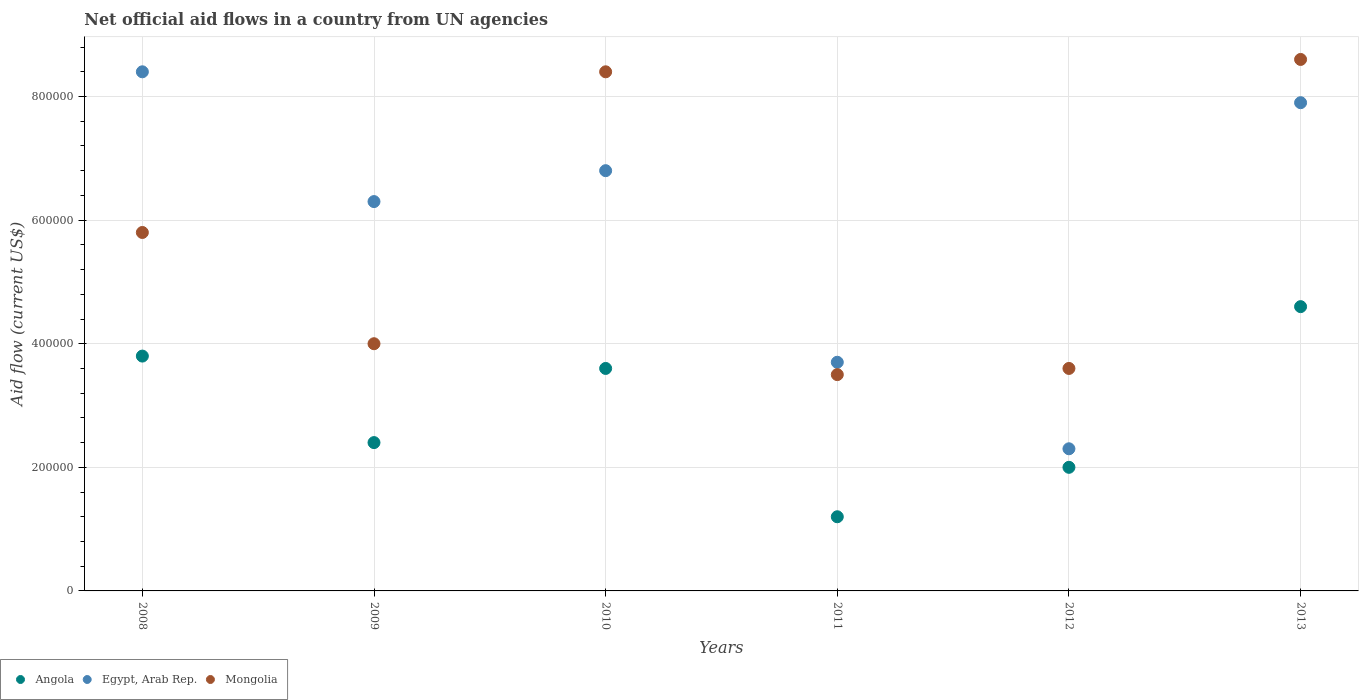How many different coloured dotlines are there?
Keep it short and to the point. 3. What is the net official aid flow in Egypt, Arab Rep. in 2013?
Give a very brief answer. 7.90e+05. Across all years, what is the maximum net official aid flow in Mongolia?
Give a very brief answer. 8.60e+05. Across all years, what is the minimum net official aid flow in Egypt, Arab Rep.?
Offer a terse response. 2.30e+05. In which year was the net official aid flow in Angola maximum?
Offer a very short reply. 2013. In which year was the net official aid flow in Egypt, Arab Rep. minimum?
Keep it short and to the point. 2012. What is the total net official aid flow in Angola in the graph?
Make the answer very short. 1.76e+06. What is the difference between the net official aid flow in Mongolia in 2010 and that in 2012?
Ensure brevity in your answer.  4.80e+05. What is the difference between the net official aid flow in Mongolia in 2013 and the net official aid flow in Angola in 2012?
Ensure brevity in your answer.  6.60e+05. What is the average net official aid flow in Mongolia per year?
Give a very brief answer. 5.65e+05. In the year 2013, what is the difference between the net official aid flow in Angola and net official aid flow in Egypt, Arab Rep.?
Give a very brief answer. -3.30e+05. What is the ratio of the net official aid flow in Angola in 2008 to that in 2010?
Your answer should be very brief. 1.06. Is the difference between the net official aid flow in Angola in 2010 and 2012 greater than the difference between the net official aid flow in Egypt, Arab Rep. in 2010 and 2012?
Your response must be concise. No. What is the difference between the highest and the lowest net official aid flow in Egypt, Arab Rep.?
Offer a very short reply. 6.10e+05. How many years are there in the graph?
Provide a succinct answer. 6. Does the graph contain grids?
Make the answer very short. Yes. Where does the legend appear in the graph?
Your answer should be very brief. Bottom left. What is the title of the graph?
Your answer should be compact. Net official aid flows in a country from UN agencies. What is the label or title of the Y-axis?
Your answer should be very brief. Aid flow (current US$). What is the Aid flow (current US$) in Egypt, Arab Rep. in 2008?
Your answer should be compact. 8.40e+05. What is the Aid flow (current US$) of Mongolia in 2008?
Keep it short and to the point. 5.80e+05. What is the Aid flow (current US$) of Egypt, Arab Rep. in 2009?
Make the answer very short. 6.30e+05. What is the Aid flow (current US$) in Mongolia in 2009?
Your response must be concise. 4.00e+05. What is the Aid flow (current US$) of Egypt, Arab Rep. in 2010?
Offer a terse response. 6.80e+05. What is the Aid flow (current US$) in Mongolia in 2010?
Your answer should be compact. 8.40e+05. What is the Aid flow (current US$) in Mongolia in 2011?
Your answer should be compact. 3.50e+05. What is the Aid flow (current US$) in Egypt, Arab Rep. in 2012?
Provide a succinct answer. 2.30e+05. What is the Aid flow (current US$) of Mongolia in 2012?
Keep it short and to the point. 3.60e+05. What is the Aid flow (current US$) in Angola in 2013?
Offer a very short reply. 4.60e+05. What is the Aid flow (current US$) of Egypt, Arab Rep. in 2013?
Keep it short and to the point. 7.90e+05. What is the Aid flow (current US$) in Mongolia in 2013?
Provide a succinct answer. 8.60e+05. Across all years, what is the maximum Aid flow (current US$) in Egypt, Arab Rep.?
Provide a succinct answer. 8.40e+05. Across all years, what is the maximum Aid flow (current US$) of Mongolia?
Give a very brief answer. 8.60e+05. Across all years, what is the minimum Aid flow (current US$) in Angola?
Your answer should be very brief. 1.20e+05. Across all years, what is the minimum Aid flow (current US$) in Mongolia?
Offer a terse response. 3.50e+05. What is the total Aid flow (current US$) in Angola in the graph?
Keep it short and to the point. 1.76e+06. What is the total Aid flow (current US$) in Egypt, Arab Rep. in the graph?
Your response must be concise. 3.54e+06. What is the total Aid flow (current US$) in Mongolia in the graph?
Offer a terse response. 3.39e+06. What is the difference between the Aid flow (current US$) in Angola in 2008 and that in 2009?
Your answer should be compact. 1.40e+05. What is the difference between the Aid flow (current US$) of Egypt, Arab Rep. in 2008 and that in 2009?
Provide a succinct answer. 2.10e+05. What is the difference between the Aid flow (current US$) in Mongolia in 2008 and that in 2009?
Offer a very short reply. 1.80e+05. What is the difference between the Aid flow (current US$) in Angola in 2008 and that in 2010?
Offer a very short reply. 2.00e+04. What is the difference between the Aid flow (current US$) in Mongolia in 2008 and that in 2011?
Your answer should be very brief. 2.30e+05. What is the difference between the Aid flow (current US$) in Angola in 2008 and that in 2012?
Make the answer very short. 1.80e+05. What is the difference between the Aid flow (current US$) of Mongolia in 2008 and that in 2012?
Give a very brief answer. 2.20e+05. What is the difference between the Aid flow (current US$) of Angola in 2008 and that in 2013?
Offer a terse response. -8.00e+04. What is the difference between the Aid flow (current US$) in Mongolia in 2008 and that in 2013?
Offer a terse response. -2.80e+05. What is the difference between the Aid flow (current US$) in Angola in 2009 and that in 2010?
Your answer should be very brief. -1.20e+05. What is the difference between the Aid flow (current US$) in Egypt, Arab Rep. in 2009 and that in 2010?
Keep it short and to the point. -5.00e+04. What is the difference between the Aid flow (current US$) in Mongolia in 2009 and that in 2010?
Your answer should be very brief. -4.40e+05. What is the difference between the Aid flow (current US$) in Angola in 2009 and that in 2011?
Your response must be concise. 1.20e+05. What is the difference between the Aid flow (current US$) of Mongolia in 2009 and that in 2011?
Ensure brevity in your answer.  5.00e+04. What is the difference between the Aid flow (current US$) in Mongolia in 2009 and that in 2012?
Your answer should be compact. 4.00e+04. What is the difference between the Aid flow (current US$) in Mongolia in 2009 and that in 2013?
Keep it short and to the point. -4.60e+05. What is the difference between the Aid flow (current US$) of Angola in 2010 and that in 2011?
Your response must be concise. 2.40e+05. What is the difference between the Aid flow (current US$) of Egypt, Arab Rep. in 2010 and that in 2011?
Offer a very short reply. 3.10e+05. What is the difference between the Aid flow (current US$) of Angola in 2010 and that in 2012?
Offer a very short reply. 1.60e+05. What is the difference between the Aid flow (current US$) in Mongolia in 2010 and that in 2012?
Ensure brevity in your answer.  4.80e+05. What is the difference between the Aid flow (current US$) in Angola in 2010 and that in 2013?
Your answer should be compact. -1.00e+05. What is the difference between the Aid flow (current US$) of Egypt, Arab Rep. in 2010 and that in 2013?
Your answer should be compact. -1.10e+05. What is the difference between the Aid flow (current US$) in Mongolia in 2010 and that in 2013?
Your answer should be very brief. -2.00e+04. What is the difference between the Aid flow (current US$) of Angola in 2011 and that in 2012?
Provide a short and direct response. -8.00e+04. What is the difference between the Aid flow (current US$) of Egypt, Arab Rep. in 2011 and that in 2012?
Make the answer very short. 1.40e+05. What is the difference between the Aid flow (current US$) in Mongolia in 2011 and that in 2012?
Keep it short and to the point. -10000. What is the difference between the Aid flow (current US$) in Angola in 2011 and that in 2013?
Your answer should be very brief. -3.40e+05. What is the difference between the Aid flow (current US$) of Egypt, Arab Rep. in 2011 and that in 2013?
Your answer should be very brief. -4.20e+05. What is the difference between the Aid flow (current US$) of Mongolia in 2011 and that in 2013?
Give a very brief answer. -5.10e+05. What is the difference between the Aid flow (current US$) in Angola in 2012 and that in 2013?
Keep it short and to the point. -2.60e+05. What is the difference between the Aid flow (current US$) of Egypt, Arab Rep. in 2012 and that in 2013?
Give a very brief answer. -5.60e+05. What is the difference between the Aid flow (current US$) in Mongolia in 2012 and that in 2013?
Your answer should be very brief. -5.00e+05. What is the difference between the Aid flow (current US$) in Angola in 2008 and the Aid flow (current US$) in Mongolia in 2009?
Ensure brevity in your answer.  -2.00e+04. What is the difference between the Aid flow (current US$) of Angola in 2008 and the Aid flow (current US$) of Egypt, Arab Rep. in 2010?
Make the answer very short. -3.00e+05. What is the difference between the Aid flow (current US$) of Angola in 2008 and the Aid flow (current US$) of Mongolia in 2010?
Your response must be concise. -4.60e+05. What is the difference between the Aid flow (current US$) of Angola in 2008 and the Aid flow (current US$) of Mongolia in 2011?
Your answer should be compact. 3.00e+04. What is the difference between the Aid flow (current US$) of Egypt, Arab Rep. in 2008 and the Aid flow (current US$) of Mongolia in 2012?
Make the answer very short. 4.80e+05. What is the difference between the Aid flow (current US$) of Angola in 2008 and the Aid flow (current US$) of Egypt, Arab Rep. in 2013?
Offer a very short reply. -4.10e+05. What is the difference between the Aid flow (current US$) in Angola in 2008 and the Aid flow (current US$) in Mongolia in 2013?
Keep it short and to the point. -4.80e+05. What is the difference between the Aid flow (current US$) of Angola in 2009 and the Aid flow (current US$) of Egypt, Arab Rep. in 2010?
Offer a very short reply. -4.40e+05. What is the difference between the Aid flow (current US$) in Angola in 2009 and the Aid flow (current US$) in Mongolia in 2010?
Offer a terse response. -6.00e+05. What is the difference between the Aid flow (current US$) in Egypt, Arab Rep. in 2009 and the Aid flow (current US$) in Mongolia in 2010?
Your answer should be compact. -2.10e+05. What is the difference between the Aid flow (current US$) in Angola in 2009 and the Aid flow (current US$) in Mongolia in 2011?
Offer a very short reply. -1.10e+05. What is the difference between the Aid flow (current US$) of Angola in 2009 and the Aid flow (current US$) of Egypt, Arab Rep. in 2012?
Give a very brief answer. 10000. What is the difference between the Aid flow (current US$) of Angola in 2009 and the Aid flow (current US$) of Egypt, Arab Rep. in 2013?
Ensure brevity in your answer.  -5.50e+05. What is the difference between the Aid flow (current US$) in Angola in 2009 and the Aid flow (current US$) in Mongolia in 2013?
Provide a succinct answer. -6.20e+05. What is the difference between the Aid flow (current US$) of Angola in 2010 and the Aid flow (current US$) of Mongolia in 2012?
Offer a terse response. 0. What is the difference between the Aid flow (current US$) of Egypt, Arab Rep. in 2010 and the Aid flow (current US$) of Mongolia in 2012?
Make the answer very short. 3.20e+05. What is the difference between the Aid flow (current US$) of Angola in 2010 and the Aid flow (current US$) of Egypt, Arab Rep. in 2013?
Your answer should be very brief. -4.30e+05. What is the difference between the Aid flow (current US$) in Angola in 2010 and the Aid flow (current US$) in Mongolia in 2013?
Your answer should be compact. -5.00e+05. What is the difference between the Aid flow (current US$) in Angola in 2011 and the Aid flow (current US$) in Egypt, Arab Rep. in 2012?
Your answer should be compact. -1.10e+05. What is the difference between the Aid flow (current US$) in Angola in 2011 and the Aid flow (current US$) in Egypt, Arab Rep. in 2013?
Ensure brevity in your answer.  -6.70e+05. What is the difference between the Aid flow (current US$) in Angola in 2011 and the Aid flow (current US$) in Mongolia in 2013?
Ensure brevity in your answer.  -7.40e+05. What is the difference between the Aid flow (current US$) in Egypt, Arab Rep. in 2011 and the Aid flow (current US$) in Mongolia in 2013?
Ensure brevity in your answer.  -4.90e+05. What is the difference between the Aid flow (current US$) in Angola in 2012 and the Aid flow (current US$) in Egypt, Arab Rep. in 2013?
Offer a very short reply. -5.90e+05. What is the difference between the Aid flow (current US$) in Angola in 2012 and the Aid flow (current US$) in Mongolia in 2013?
Offer a terse response. -6.60e+05. What is the difference between the Aid flow (current US$) of Egypt, Arab Rep. in 2012 and the Aid flow (current US$) of Mongolia in 2013?
Provide a succinct answer. -6.30e+05. What is the average Aid flow (current US$) of Angola per year?
Your response must be concise. 2.93e+05. What is the average Aid flow (current US$) in Egypt, Arab Rep. per year?
Your answer should be very brief. 5.90e+05. What is the average Aid flow (current US$) in Mongolia per year?
Provide a succinct answer. 5.65e+05. In the year 2008, what is the difference between the Aid flow (current US$) in Angola and Aid flow (current US$) in Egypt, Arab Rep.?
Make the answer very short. -4.60e+05. In the year 2008, what is the difference between the Aid flow (current US$) of Egypt, Arab Rep. and Aid flow (current US$) of Mongolia?
Give a very brief answer. 2.60e+05. In the year 2009, what is the difference between the Aid flow (current US$) of Angola and Aid flow (current US$) of Egypt, Arab Rep.?
Provide a short and direct response. -3.90e+05. In the year 2010, what is the difference between the Aid flow (current US$) of Angola and Aid flow (current US$) of Egypt, Arab Rep.?
Keep it short and to the point. -3.20e+05. In the year 2010, what is the difference between the Aid flow (current US$) in Angola and Aid flow (current US$) in Mongolia?
Keep it short and to the point. -4.80e+05. In the year 2011, what is the difference between the Aid flow (current US$) in Angola and Aid flow (current US$) in Egypt, Arab Rep.?
Your answer should be compact. -2.50e+05. In the year 2011, what is the difference between the Aid flow (current US$) of Egypt, Arab Rep. and Aid flow (current US$) of Mongolia?
Your answer should be very brief. 2.00e+04. In the year 2012, what is the difference between the Aid flow (current US$) in Angola and Aid flow (current US$) in Egypt, Arab Rep.?
Offer a very short reply. -3.00e+04. In the year 2012, what is the difference between the Aid flow (current US$) in Egypt, Arab Rep. and Aid flow (current US$) in Mongolia?
Offer a very short reply. -1.30e+05. In the year 2013, what is the difference between the Aid flow (current US$) in Angola and Aid flow (current US$) in Egypt, Arab Rep.?
Make the answer very short. -3.30e+05. In the year 2013, what is the difference between the Aid flow (current US$) in Angola and Aid flow (current US$) in Mongolia?
Your response must be concise. -4.00e+05. In the year 2013, what is the difference between the Aid flow (current US$) of Egypt, Arab Rep. and Aid flow (current US$) of Mongolia?
Offer a very short reply. -7.00e+04. What is the ratio of the Aid flow (current US$) in Angola in 2008 to that in 2009?
Keep it short and to the point. 1.58. What is the ratio of the Aid flow (current US$) of Mongolia in 2008 to that in 2009?
Make the answer very short. 1.45. What is the ratio of the Aid flow (current US$) of Angola in 2008 to that in 2010?
Your answer should be very brief. 1.06. What is the ratio of the Aid flow (current US$) of Egypt, Arab Rep. in 2008 to that in 2010?
Your answer should be very brief. 1.24. What is the ratio of the Aid flow (current US$) of Mongolia in 2008 to that in 2010?
Ensure brevity in your answer.  0.69. What is the ratio of the Aid flow (current US$) in Angola in 2008 to that in 2011?
Your response must be concise. 3.17. What is the ratio of the Aid flow (current US$) of Egypt, Arab Rep. in 2008 to that in 2011?
Keep it short and to the point. 2.27. What is the ratio of the Aid flow (current US$) in Mongolia in 2008 to that in 2011?
Ensure brevity in your answer.  1.66. What is the ratio of the Aid flow (current US$) of Angola in 2008 to that in 2012?
Your answer should be compact. 1.9. What is the ratio of the Aid flow (current US$) of Egypt, Arab Rep. in 2008 to that in 2012?
Your answer should be compact. 3.65. What is the ratio of the Aid flow (current US$) of Mongolia in 2008 to that in 2012?
Offer a terse response. 1.61. What is the ratio of the Aid flow (current US$) of Angola in 2008 to that in 2013?
Provide a short and direct response. 0.83. What is the ratio of the Aid flow (current US$) in Egypt, Arab Rep. in 2008 to that in 2013?
Provide a short and direct response. 1.06. What is the ratio of the Aid flow (current US$) of Mongolia in 2008 to that in 2013?
Keep it short and to the point. 0.67. What is the ratio of the Aid flow (current US$) of Egypt, Arab Rep. in 2009 to that in 2010?
Provide a succinct answer. 0.93. What is the ratio of the Aid flow (current US$) of Mongolia in 2009 to that in 2010?
Offer a very short reply. 0.48. What is the ratio of the Aid flow (current US$) of Egypt, Arab Rep. in 2009 to that in 2011?
Your answer should be compact. 1.7. What is the ratio of the Aid flow (current US$) in Mongolia in 2009 to that in 2011?
Offer a terse response. 1.14. What is the ratio of the Aid flow (current US$) of Egypt, Arab Rep. in 2009 to that in 2012?
Keep it short and to the point. 2.74. What is the ratio of the Aid flow (current US$) in Angola in 2009 to that in 2013?
Offer a terse response. 0.52. What is the ratio of the Aid flow (current US$) of Egypt, Arab Rep. in 2009 to that in 2013?
Ensure brevity in your answer.  0.8. What is the ratio of the Aid flow (current US$) of Mongolia in 2009 to that in 2013?
Your answer should be compact. 0.47. What is the ratio of the Aid flow (current US$) in Egypt, Arab Rep. in 2010 to that in 2011?
Your answer should be very brief. 1.84. What is the ratio of the Aid flow (current US$) of Egypt, Arab Rep. in 2010 to that in 2012?
Your response must be concise. 2.96. What is the ratio of the Aid flow (current US$) of Mongolia in 2010 to that in 2012?
Give a very brief answer. 2.33. What is the ratio of the Aid flow (current US$) of Angola in 2010 to that in 2013?
Provide a short and direct response. 0.78. What is the ratio of the Aid flow (current US$) of Egypt, Arab Rep. in 2010 to that in 2013?
Keep it short and to the point. 0.86. What is the ratio of the Aid flow (current US$) of Mongolia in 2010 to that in 2013?
Keep it short and to the point. 0.98. What is the ratio of the Aid flow (current US$) in Egypt, Arab Rep. in 2011 to that in 2012?
Offer a terse response. 1.61. What is the ratio of the Aid flow (current US$) in Mongolia in 2011 to that in 2012?
Offer a very short reply. 0.97. What is the ratio of the Aid flow (current US$) of Angola in 2011 to that in 2013?
Offer a very short reply. 0.26. What is the ratio of the Aid flow (current US$) of Egypt, Arab Rep. in 2011 to that in 2013?
Provide a succinct answer. 0.47. What is the ratio of the Aid flow (current US$) in Mongolia in 2011 to that in 2013?
Provide a succinct answer. 0.41. What is the ratio of the Aid flow (current US$) of Angola in 2012 to that in 2013?
Your response must be concise. 0.43. What is the ratio of the Aid flow (current US$) in Egypt, Arab Rep. in 2012 to that in 2013?
Give a very brief answer. 0.29. What is the ratio of the Aid flow (current US$) in Mongolia in 2012 to that in 2013?
Your answer should be very brief. 0.42. What is the difference between the highest and the second highest Aid flow (current US$) of Egypt, Arab Rep.?
Offer a very short reply. 5.00e+04. What is the difference between the highest and the lowest Aid flow (current US$) of Angola?
Make the answer very short. 3.40e+05. What is the difference between the highest and the lowest Aid flow (current US$) in Mongolia?
Provide a short and direct response. 5.10e+05. 